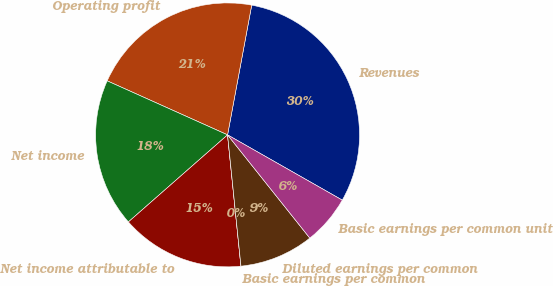Convert chart to OTSL. <chart><loc_0><loc_0><loc_500><loc_500><pie_chart><fcel>Revenues<fcel>Operating profit<fcel>Net income<fcel>Net income attributable to<fcel>Basic earnings per common<fcel>Diluted earnings per common<fcel>Basic earnings per common unit<nl><fcel>30.3%<fcel>21.21%<fcel>18.18%<fcel>15.15%<fcel>0.0%<fcel>9.09%<fcel>6.06%<nl></chart> 